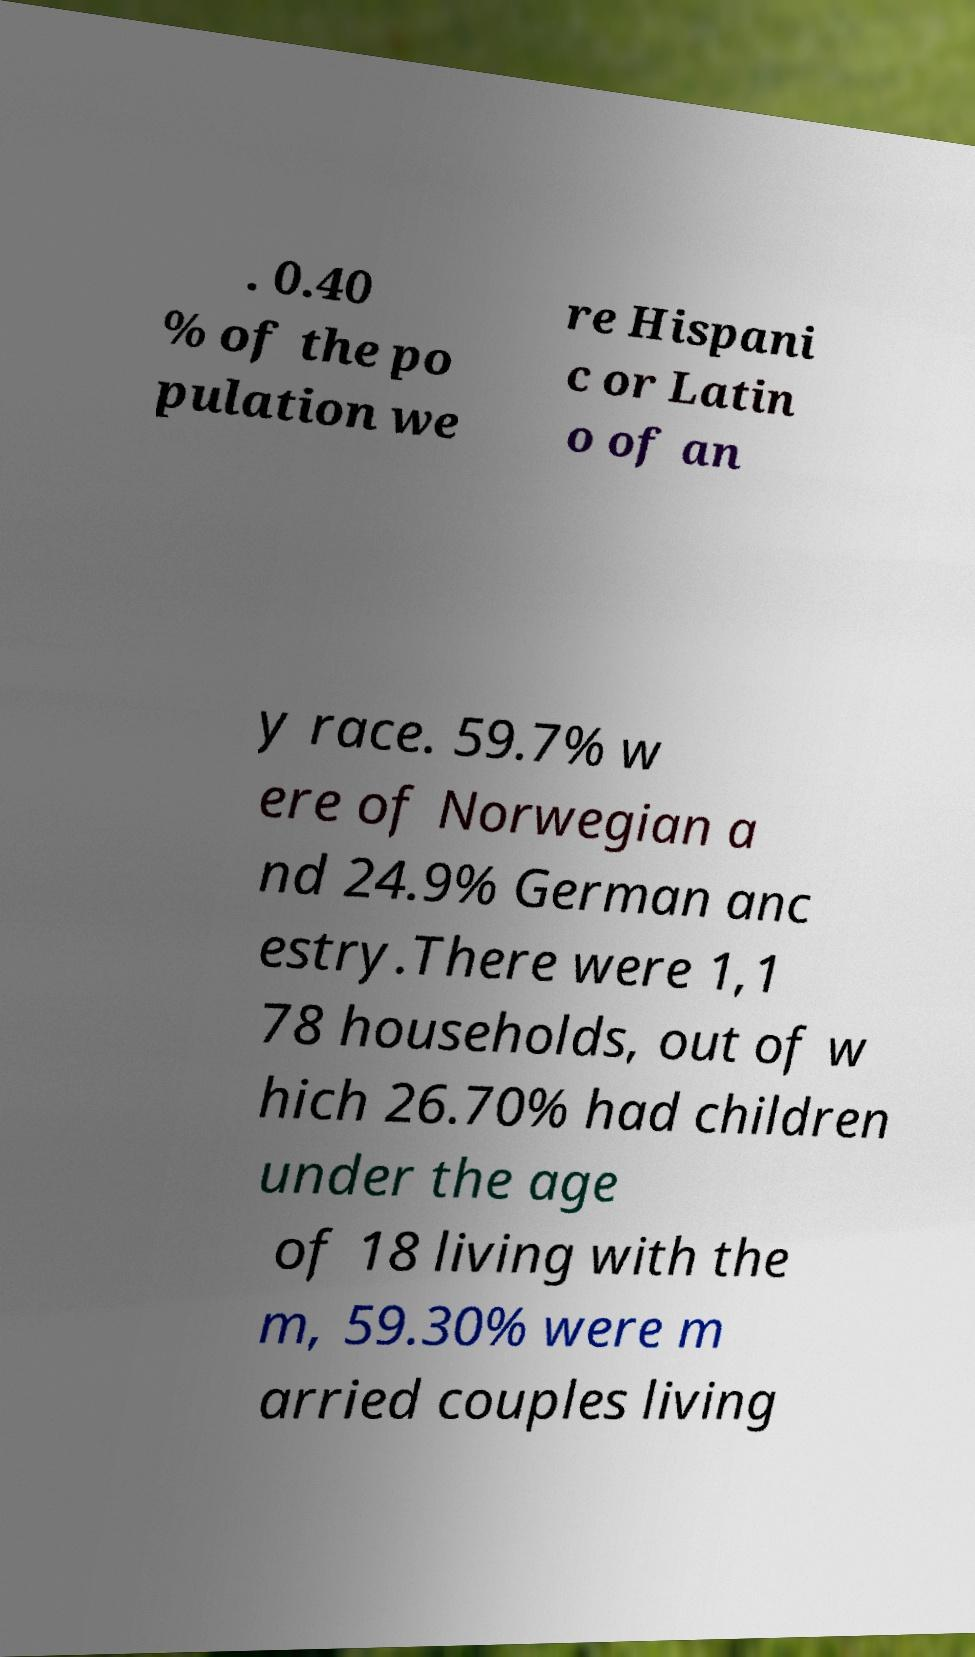What messages or text are displayed in this image? I need them in a readable, typed format. . 0.40 % of the po pulation we re Hispani c or Latin o of an y race. 59.7% w ere of Norwegian a nd 24.9% German anc estry.There were 1,1 78 households, out of w hich 26.70% had children under the age of 18 living with the m, 59.30% were m arried couples living 